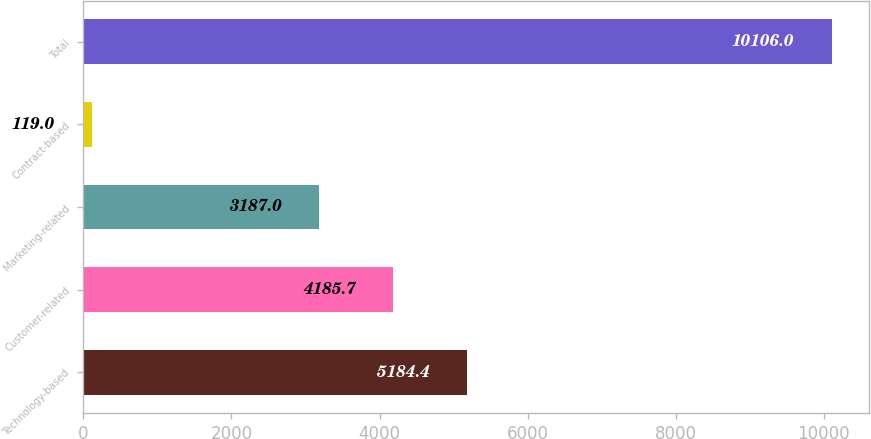Convert chart to OTSL. <chart><loc_0><loc_0><loc_500><loc_500><bar_chart><fcel>Technology-based<fcel>Customer-related<fcel>Marketing-related<fcel>Contract-based<fcel>Total<nl><fcel>5184.4<fcel>4185.7<fcel>3187<fcel>119<fcel>10106<nl></chart> 